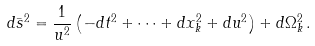Convert formula to latex. <formula><loc_0><loc_0><loc_500><loc_500>d \bar { s } ^ { 2 } = \frac { 1 } { { u } ^ { 2 } } \left ( - d t ^ { 2 } + \dots + d x _ { k } ^ { 2 } + d { u } ^ { 2 } \right ) + d \Omega _ { k } ^ { 2 } \, .</formula> 